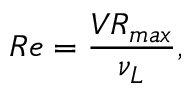Convert formula to latex. <formula><loc_0><loc_0><loc_500><loc_500>R e = { \frac { V R _ { \max } } { \nu _ { L } } } ,</formula> 